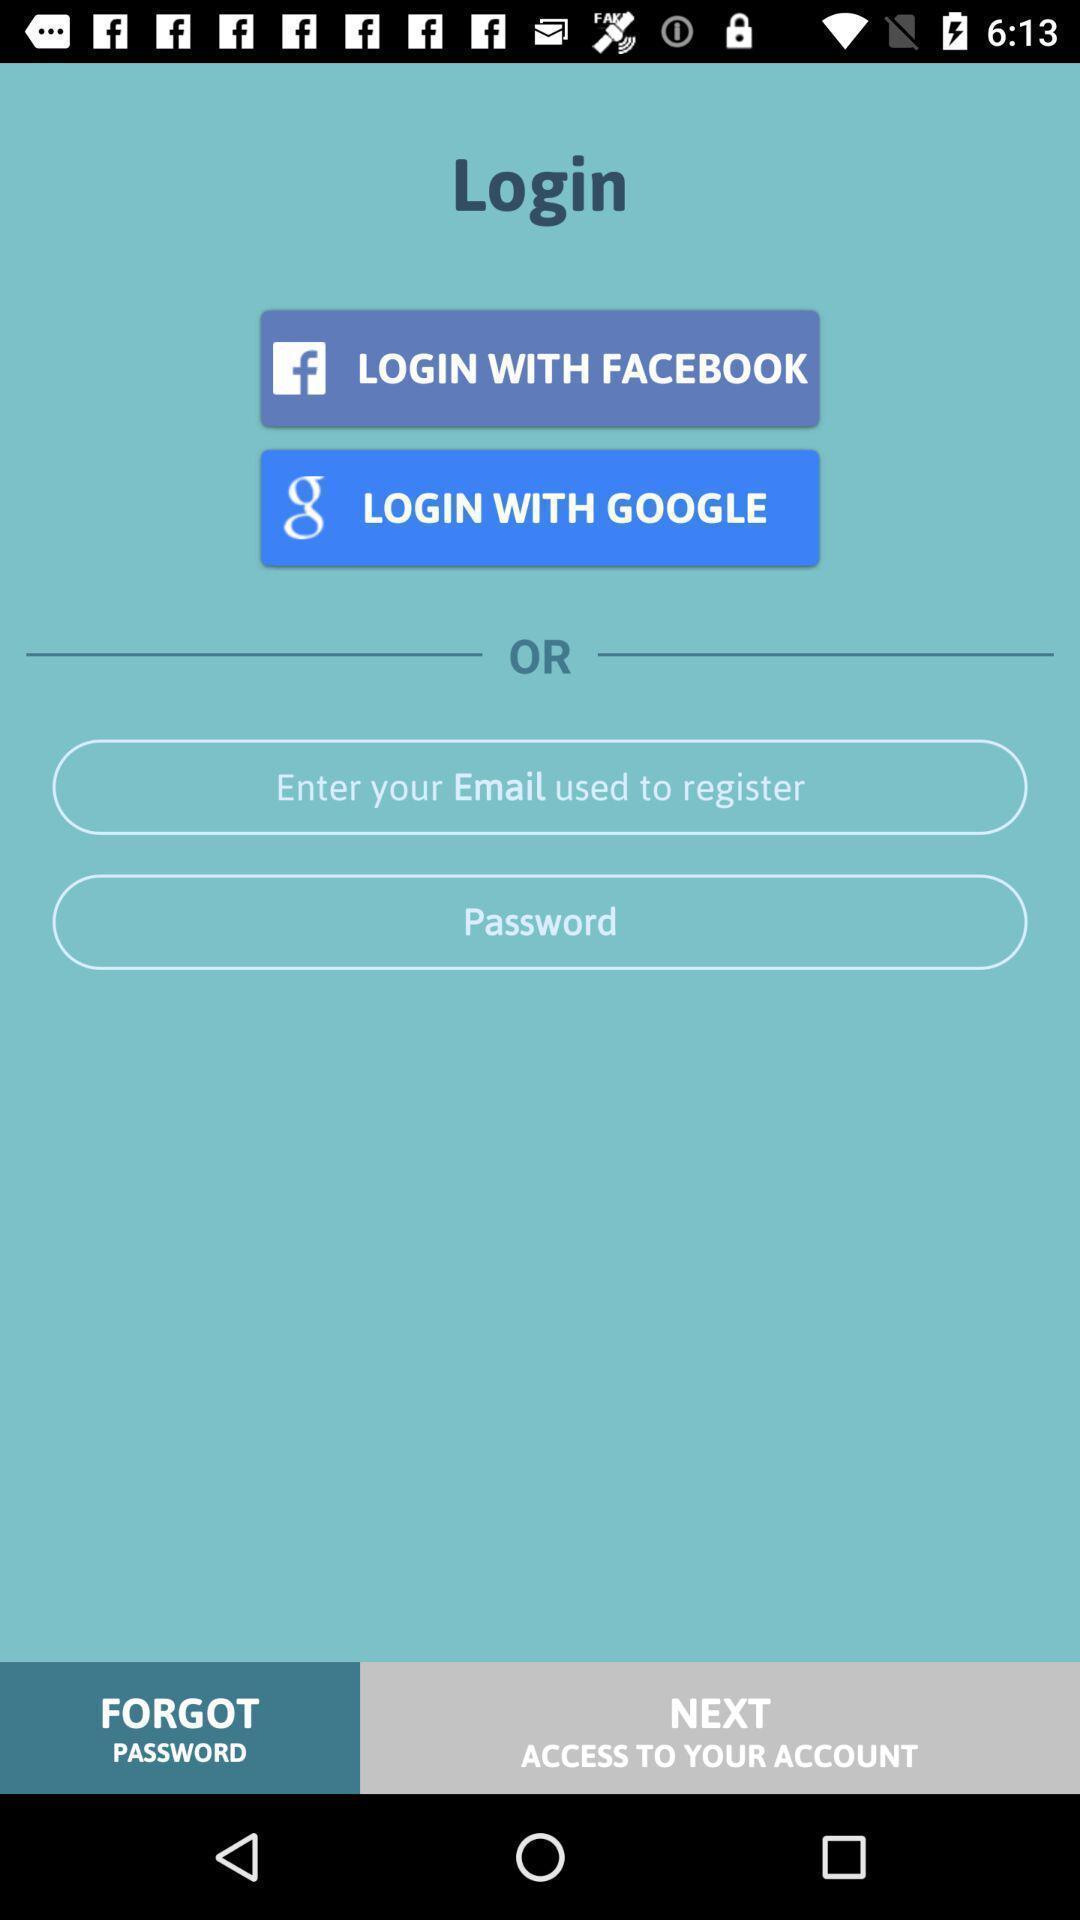What details can you identify in this image? Screen showing log in page. 